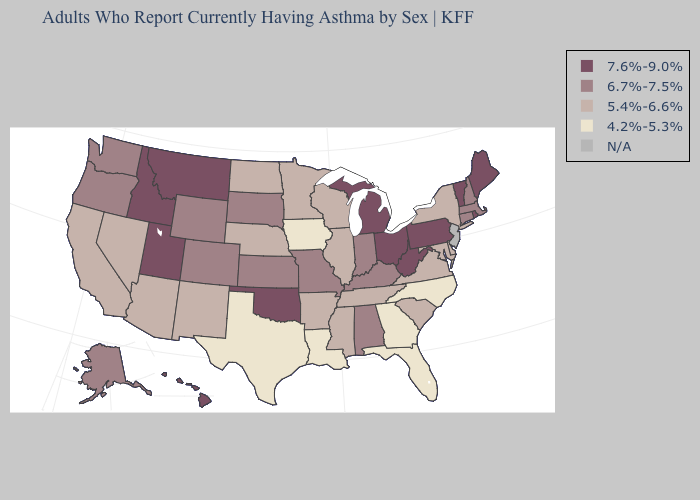What is the highest value in the West ?
Be succinct. 7.6%-9.0%. Name the states that have a value in the range 5.4%-6.6%?
Concise answer only. Arizona, Arkansas, California, Delaware, Illinois, Maryland, Minnesota, Mississippi, Nebraska, Nevada, New Mexico, New York, North Dakota, South Carolina, Tennessee, Virginia, Wisconsin. Name the states that have a value in the range 4.2%-5.3%?
Keep it brief. Florida, Georgia, Iowa, Louisiana, North Carolina, Texas. Among the states that border Mississippi , which have the highest value?
Give a very brief answer. Alabama. Name the states that have a value in the range 5.4%-6.6%?
Short answer required. Arizona, Arkansas, California, Delaware, Illinois, Maryland, Minnesota, Mississippi, Nebraska, Nevada, New Mexico, New York, North Dakota, South Carolina, Tennessee, Virginia, Wisconsin. Name the states that have a value in the range 6.7%-7.5%?
Answer briefly. Alabama, Alaska, Colorado, Connecticut, Indiana, Kansas, Kentucky, Massachusetts, Missouri, New Hampshire, Oregon, South Dakota, Washington, Wyoming. Which states have the lowest value in the MidWest?
Keep it brief. Iowa. How many symbols are there in the legend?
Write a very short answer. 5. What is the value of Arkansas?
Quick response, please. 5.4%-6.6%. Name the states that have a value in the range 5.4%-6.6%?
Write a very short answer. Arizona, Arkansas, California, Delaware, Illinois, Maryland, Minnesota, Mississippi, Nebraska, Nevada, New Mexico, New York, North Dakota, South Carolina, Tennessee, Virginia, Wisconsin. Does Michigan have the highest value in the USA?
Quick response, please. Yes. Is the legend a continuous bar?
Concise answer only. No. What is the value of South Dakota?
Short answer required. 6.7%-7.5%. How many symbols are there in the legend?
Give a very brief answer. 5. 